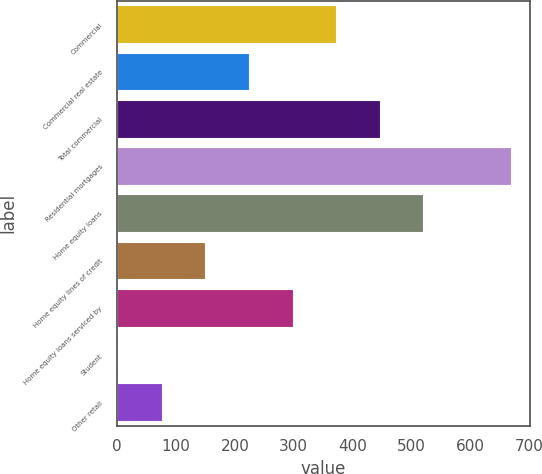Convert chart. <chart><loc_0><loc_0><loc_500><loc_500><bar_chart><fcel>Commercial<fcel>Commercial real estate<fcel>Total commercial<fcel>Residential mortgages<fcel>Home equity loans<fcel>Home equity lines of credit<fcel>Home equity loans serviced by<fcel>Student<fcel>Other retail<nl><fcel>372<fcel>224<fcel>446<fcel>668<fcel>520<fcel>150<fcel>298<fcel>2<fcel>76<nl></chart> 